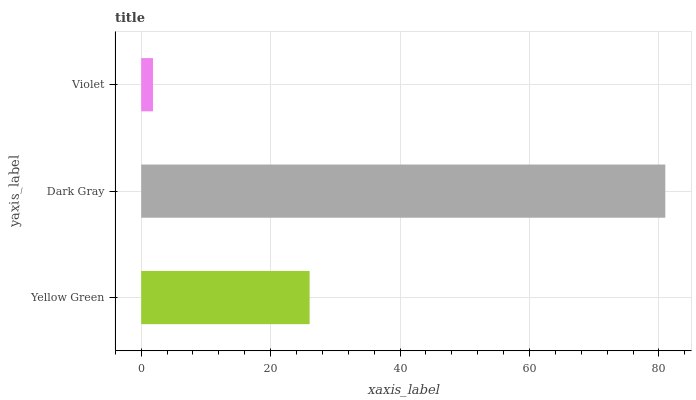Is Violet the minimum?
Answer yes or no. Yes. Is Dark Gray the maximum?
Answer yes or no. Yes. Is Dark Gray the minimum?
Answer yes or no. No. Is Violet the maximum?
Answer yes or no. No. Is Dark Gray greater than Violet?
Answer yes or no. Yes. Is Violet less than Dark Gray?
Answer yes or no. Yes. Is Violet greater than Dark Gray?
Answer yes or no. No. Is Dark Gray less than Violet?
Answer yes or no. No. Is Yellow Green the high median?
Answer yes or no. Yes. Is Yellow Green the low median?
Answer yes or no. Yes. Is Dark Gray the high median?
Answer yes or no. No. Is Dark Gray the low median?
Answer yes or no. No. 